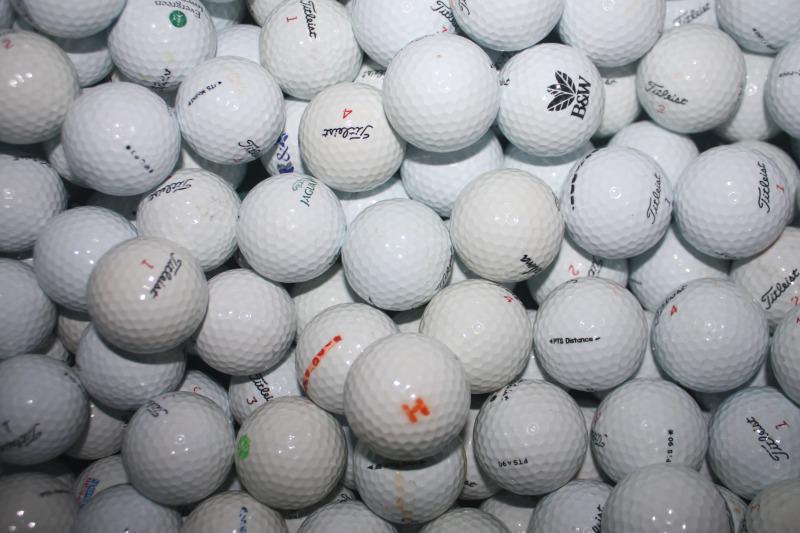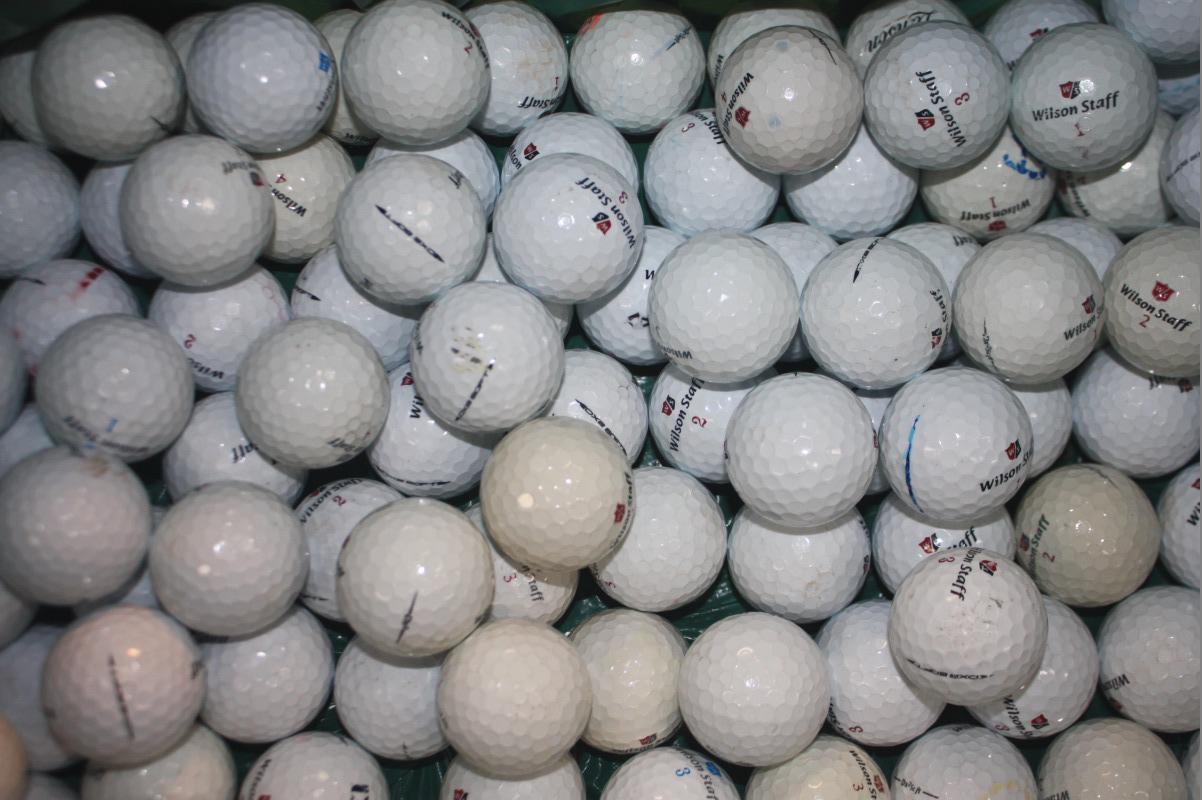The first image is the image on the left, the second image is the image on the right. Considering the images on both sides, is "Some of the balls have an orange print" valid? Answer yes or no. Yes. 